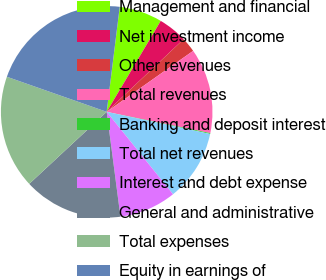<chart> <loc_0><loc_0><loc_500><loc_500><pie_chart><fcel>Management and financial<fcel>Net investment income<fcel>Other revenues<fcel>Total revenues<fcel>Banking and deposit interest<fcel>Total net revenues<fcel>Interest and debt expense<fcel>General and administrative<fcel>Total expenses<fcel>Equity in earnings of<nl><fcel>6.57%<fcel>4.42%<fcel>2.27%<fcel>13.0%<fcel>0.13%<fcel>10.86%<fcel>8.71%<fcel>15.15%<fcel>17.3%<fcel>21.59%<nl></chart> 